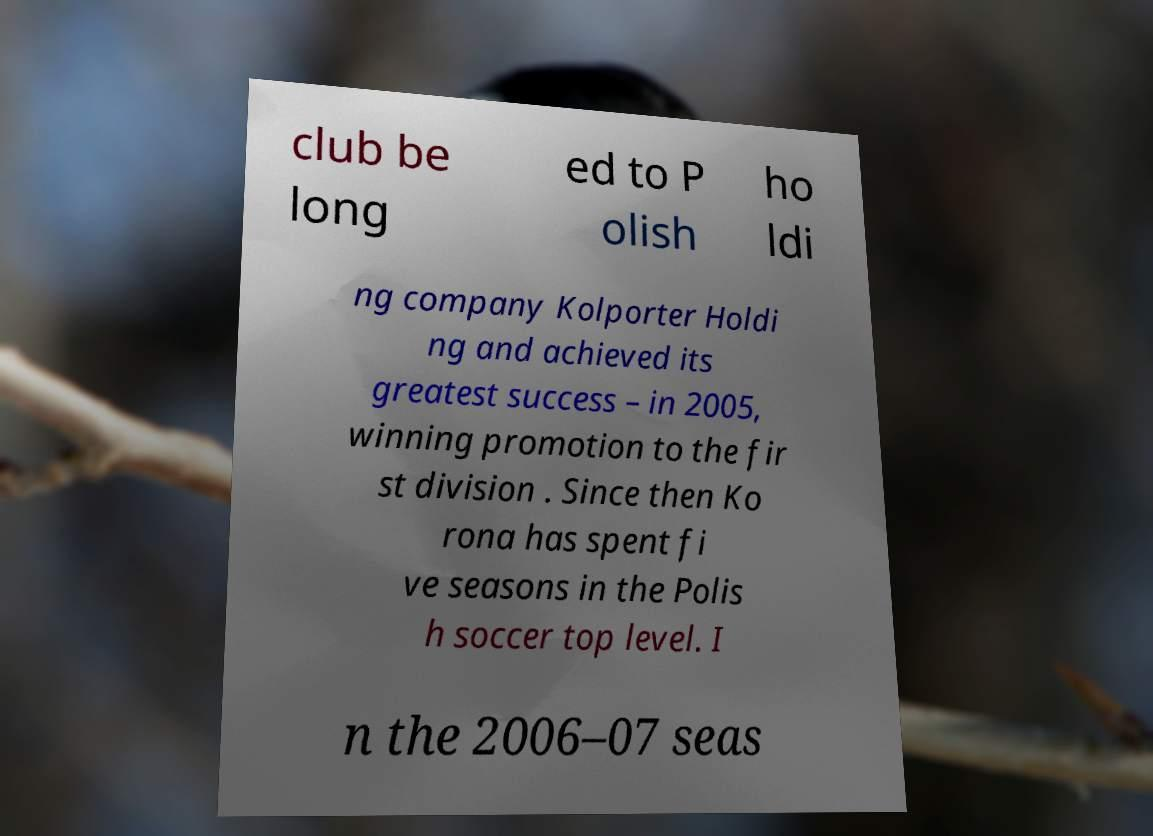What messages or text are displayed in this image? I need them in a readable, typed format. club be long ed to P olish ho ldi ng company Kolporter Holdi ng and achieved its greatest success – in 2005, winning promotion to the fir st division . Since then Ko rona has spent fi ve seasons in the Polis h soccer top level. I n the 2006–07 seas 